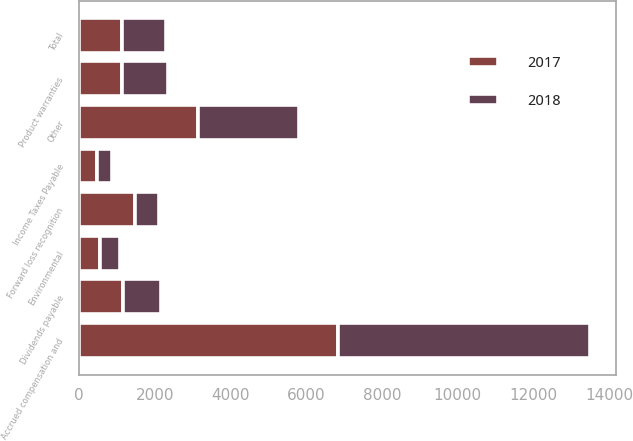Convert chart. <chart><loc_0><loc_0><loc_500><loc_500><stacked_bar_chart><ecel><fcel>Accrued compensation and<fcel>Environmental<fcel>Product warranties<fcel>Forward loss recognition<fcel>Dividends payable<fcel>Income Taxes Payable<fcel>Other<fcel>Total<nl><fcel>2017<fcel>6841<fcel>555<fcel>1127<fcel>1488<fcel>1160<fcel>485<fcel>3152<fcel>1143.5<nl><fcel>2018<fcel>6659<fcel>524<fcel>1211<fcel>622<fcel>1005<fcel>380<fcel>2668<fcel>1143.5<nl></chart> 